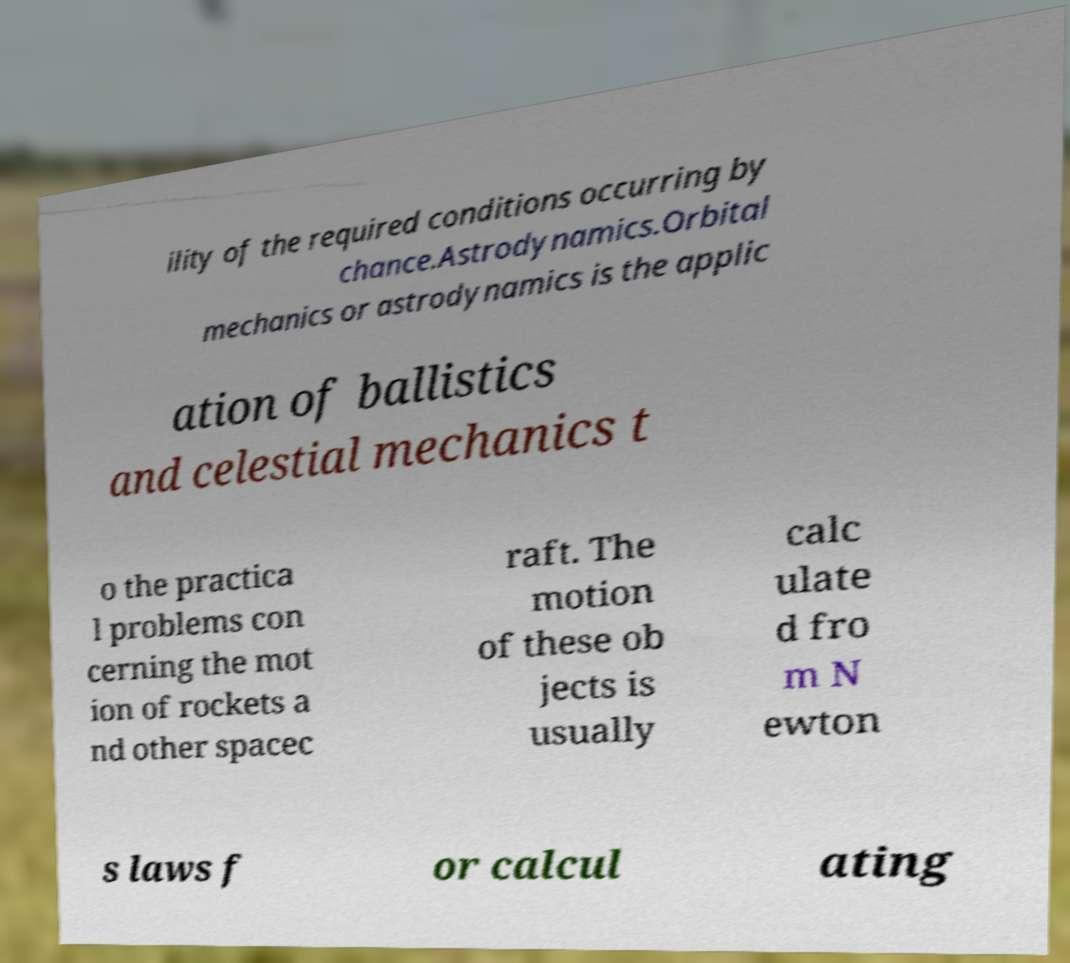Can you accurately transcribe the text from the provided image for me? ility of the required conditions occurring by chance.Astrodynamics.Orbital mechanics or astrodynamics is the applic ation of ballistics and celestial mechanics t o the practica l problems con cerning the mot ion of rockets a nd other spacec raft. The motion of these ob jects is usually calc ulate d fro m N ewton s laws f or calcul ating 